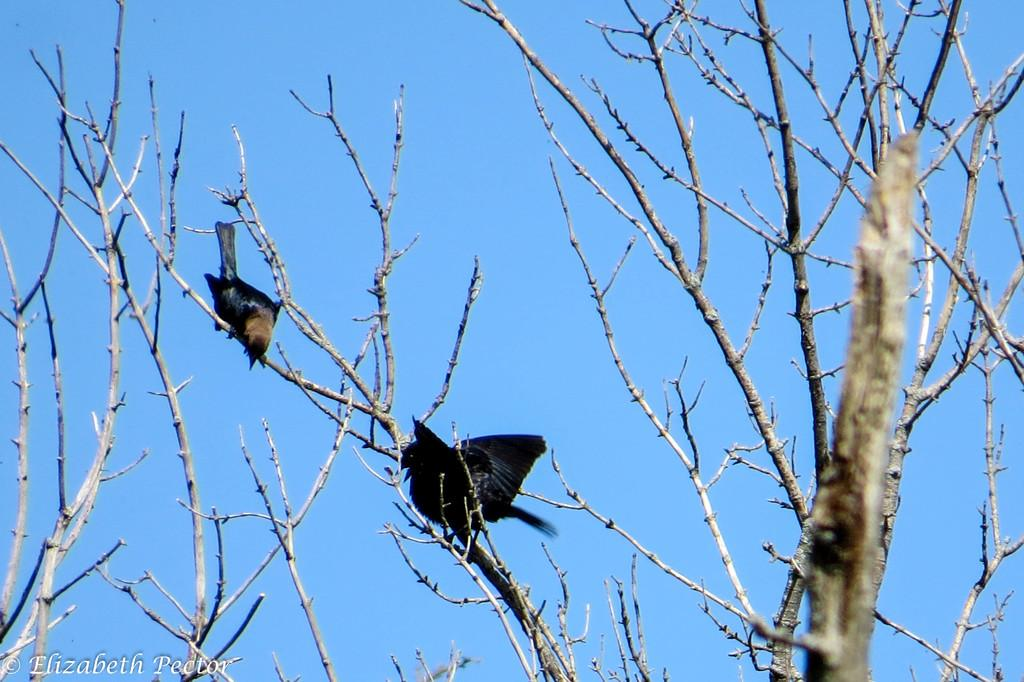What type of animals can be seen in the image? There are birds on the tree in the image. What can be seen in the background of the image? The sky is visible in the background of the image. Is there any text present in the image? Yes, there is text at the bottom of the image. Can you see any monkeys climbing the slope in the image? There is no slope or monkeys present in the image. How many ducks are swimming in the water near the tree? There is no water or ducks present in the image; it features birds on a tree with a visible sky and text at the bottom. 